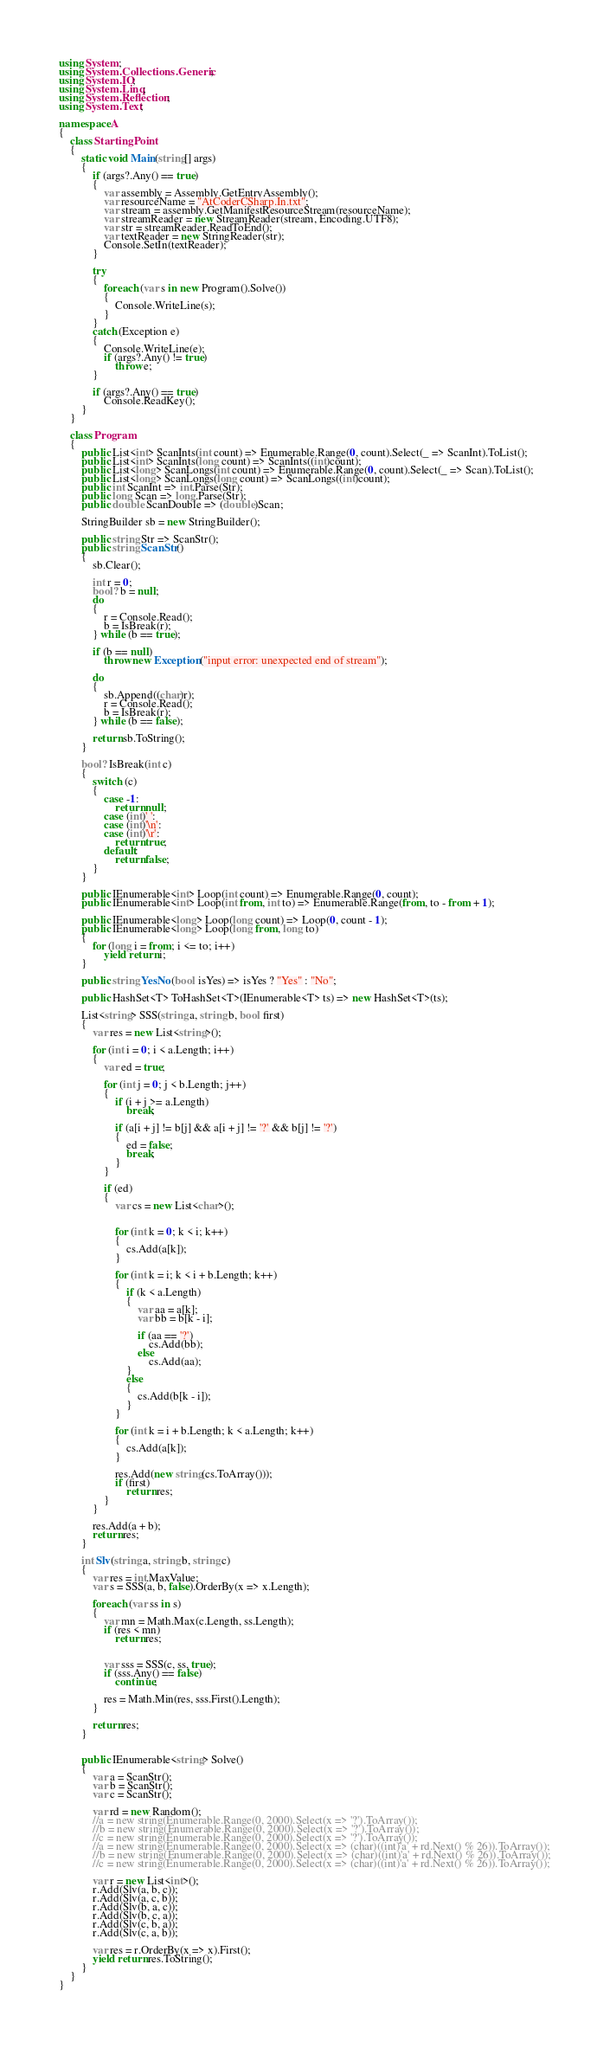Convert code to text. <code><loc_0><loc_0><loc_500><loc_500><_C#_>using System;
using System.Collections.Generic;
using System.IO;
using System.Linq;
using System.Reflection;
using System.Text;

namespace A
{
    class StartingPoint
    {
        static void Main(string[] args)
        {
            if (args?.Any() == true)
            {
                var assembly = Assembly.GetEntryAssembly();
                var resourceName = "AtCoderCSharp.In.txt";
                var stream = assembly.GetManifestResourceStream(resourceName);
                var streamReader = new StreamReader(stream, Encoding.UTF8);
                var str = streamReader.ReadToEnd();
                var textReader = new StringReader(str);
                Console.SetIn(textReader);
            }

            try
            {
                foreach (var s in new Program().Solve())
                {
                    Console.WriteLine(s);
                }
            }
            catch (Exception e)
            {
                Console.WriteLine(e);
                if (args?.Any() != true)
                    throw e;
            }

            if (args?.Any() == true)
                Console.ReadKey();
        }
    }

    class Program
    {
        public List<int> ScanInts(int count) => Enumerable.Range(0, count).Select(_ => ScanInt).ToList();
        public List<int> ScanInts(long count) => ScanInts((int)count);
        public List<long> ScanLongs(int count) => Enumerable.Range(0, count).Select(_ => Scan).ToList();
        public List<long> ScanLongs(long count) => ScanLongs((int)count);
        public int ScanInt => int.Parse(Str);
        public long Scan => long.Parse(Str);
        public double ScanDouble => (double)Scan;

        StringBuilder sb = new StringBuilder();

        public string Str => ScanStr();
        public string ScanStr()
        {
            sb.Clear();

            int r = 0;
            bool? b = null;
            do
            {
                r = Console.Read();
                b = IsBreak(r);
            } while (b == true);

            if (b == null)
                throw new Exception("input error: unexpected end of stream");

            do
            {
                sb.Append((char)r);
                r = Console.Read();
                b = IsBreak(r);
            } while (b == false);

            return sb.ToString();
        }

        bool? IsBreak(int c)
        {
            switch (c)
            {
                case -1:
                    return null;
                case (int)' ':
                case (int)'\n':
                case (int)'\r':
                    return true;
                default:
                    return false;
            }
        }

        public IEnumerable<int> Loop(int count) => Enumerable.Range(0, count);
        public IEnumerable<int> Loop(int from, int to) => Enumerable.Range(from, to - from + 1);

        public IEnumerable<long> Loop(long count) => Loop(0, count - 1);
        public IEnumerable<long> Loop(long from, long to)
        {
            for (long i = from; i <= to; i++)
                yield return i;
        }

        public string YesNo(bool isYes) => isYes ? "Yes" : "No";

        public HashSet<T> ToHashSet<T>(IEnumerable<T> ts) => new HashSet<T>(ts);

        List<string> SSS(string a, string b, bool first)
        {
            var res = new List<string>();

            for (int i = 0; i < a.Length; i++)
            {
                var ed = true;

                for (int j = 0; j < b.Length; j++)
                {
                    if (i + j >= a.Length)
                        break;

                    if (a[i + j] != b[j] && a[i + j] != '?' && b[j] != '?')
                    {
                        ed = false;
                        break;
                    }
                }

                if (ed)
                {
                    var cs = new List<char>();


                    for (int k = 0; k < i; k++)
                    {
                        cs.Add(a[k]);
                    }

                    for (int k = i; k < i + b.Length; k++)
                    {
                        if (k < a.Length)
                        {
                            var aa = a[k];
                            var bb = b[k - i];

                            if (aa == '?')
                                cs.Add(bb);
                            else
                                cs.Add(aa);
                        }
                        else
                        {
                            cs.Add(b[k - i]);
                        }
                    }

                    for (int k = i + b.Length; k < a.Length; k++)
                    {
                        cs.Add(a[k]);
                    }

                    res.Add(new string(cs.ToArray()));
                    if (first)
                        return res;
                }
            }

            res.Add(a + b);
            return res;
        }

        int Slv(string a, string b, string c)
        {
            var res = int.MaxValue;
            var s = SSS(a, b, false).OrderBy(x => x.Length);

            foreach (var ss in s)
            {
                var mn = Math.Max(c.Length, ss.Length);
                if (res < mn)
                    return res;


                var sss = SSS(c, ss, true);
                if (sss.Any() == false)
                    continue;

                res = Math.Min(res, sss.First().Length);
            }

            return res;
        }


        public IEnumerable<string> Solve()
        {
            var a = ScanStr();
            var b = ScanStr();
            var c = ScanStr();

            var rd = new Random();
            //a = new string(Enumerable.Range(0, 2000).Select(x => '?').ToArray());
            //b = new string(Enumerable.Range(0, 2000).Select(x => '?').ToArray());
            //c = new string(Enumerable.Range(0, 2000).Select(x => '?').ToArray());
            //a = new string(Enumerable.Range(0, 2000).Select(x => (char)((int)'a' + rd.Next() % 26)).ToArray());
            //b = new string(Enumerable.Range(0, 2000).Select(x => (char)((int)'a' + rd.Next() % 26)).ToArray());
            //c = new string(Enumerable.Range(0, 2000).Select(x => (char)((int)'a' + rd.Next() % 26)).ToArray());

            var r = new List<int>();
            r.Add(Slv(a, b, c));
            r.Add(Slv(a, c, b));
            r.Add(Slv(b, a, c));
            r.Add(Slv(b, c, a));
            r.Add(Slv(c, b, a));
            r.Add(Slv(c, a, b));

            var res = r.OrderBy(x => x).First();
            yield return res.ToString();
        }
    }
}</code> 